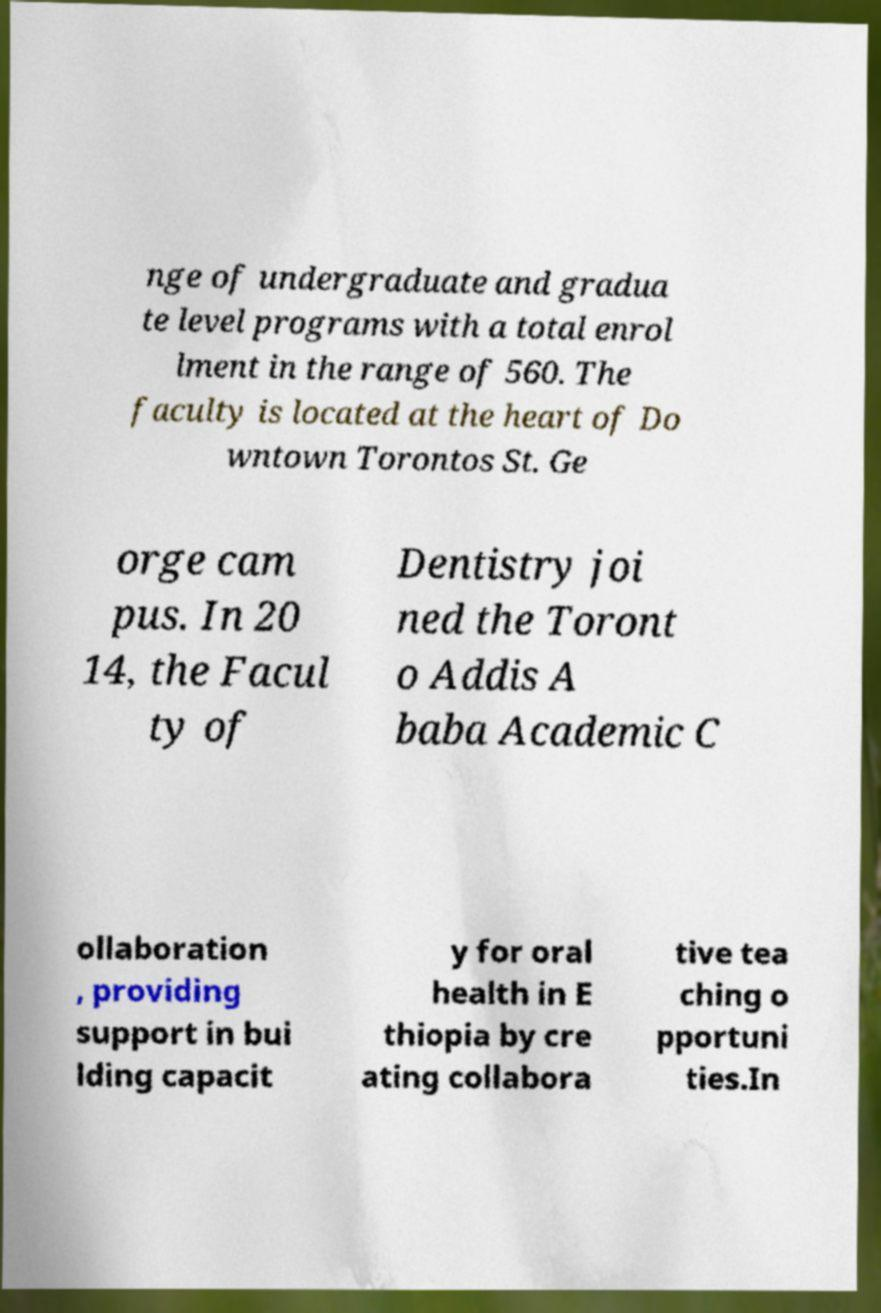Please identify and transcribe the text found in this image. nge of undergraduate and gradua te level programs with a total enrol lment in the range of 560. The faculty is located at the heart of Do wntown Torontos St. Ge orge cam pus. In 20 14, the Facul ty of Dentistry joi ned the Toront o Addis A baba Academic C ollaboration , providing support in bui lding capacit y for oral health in E thiopia by cre ating collabora tive tea ching o pportuni ties.In 